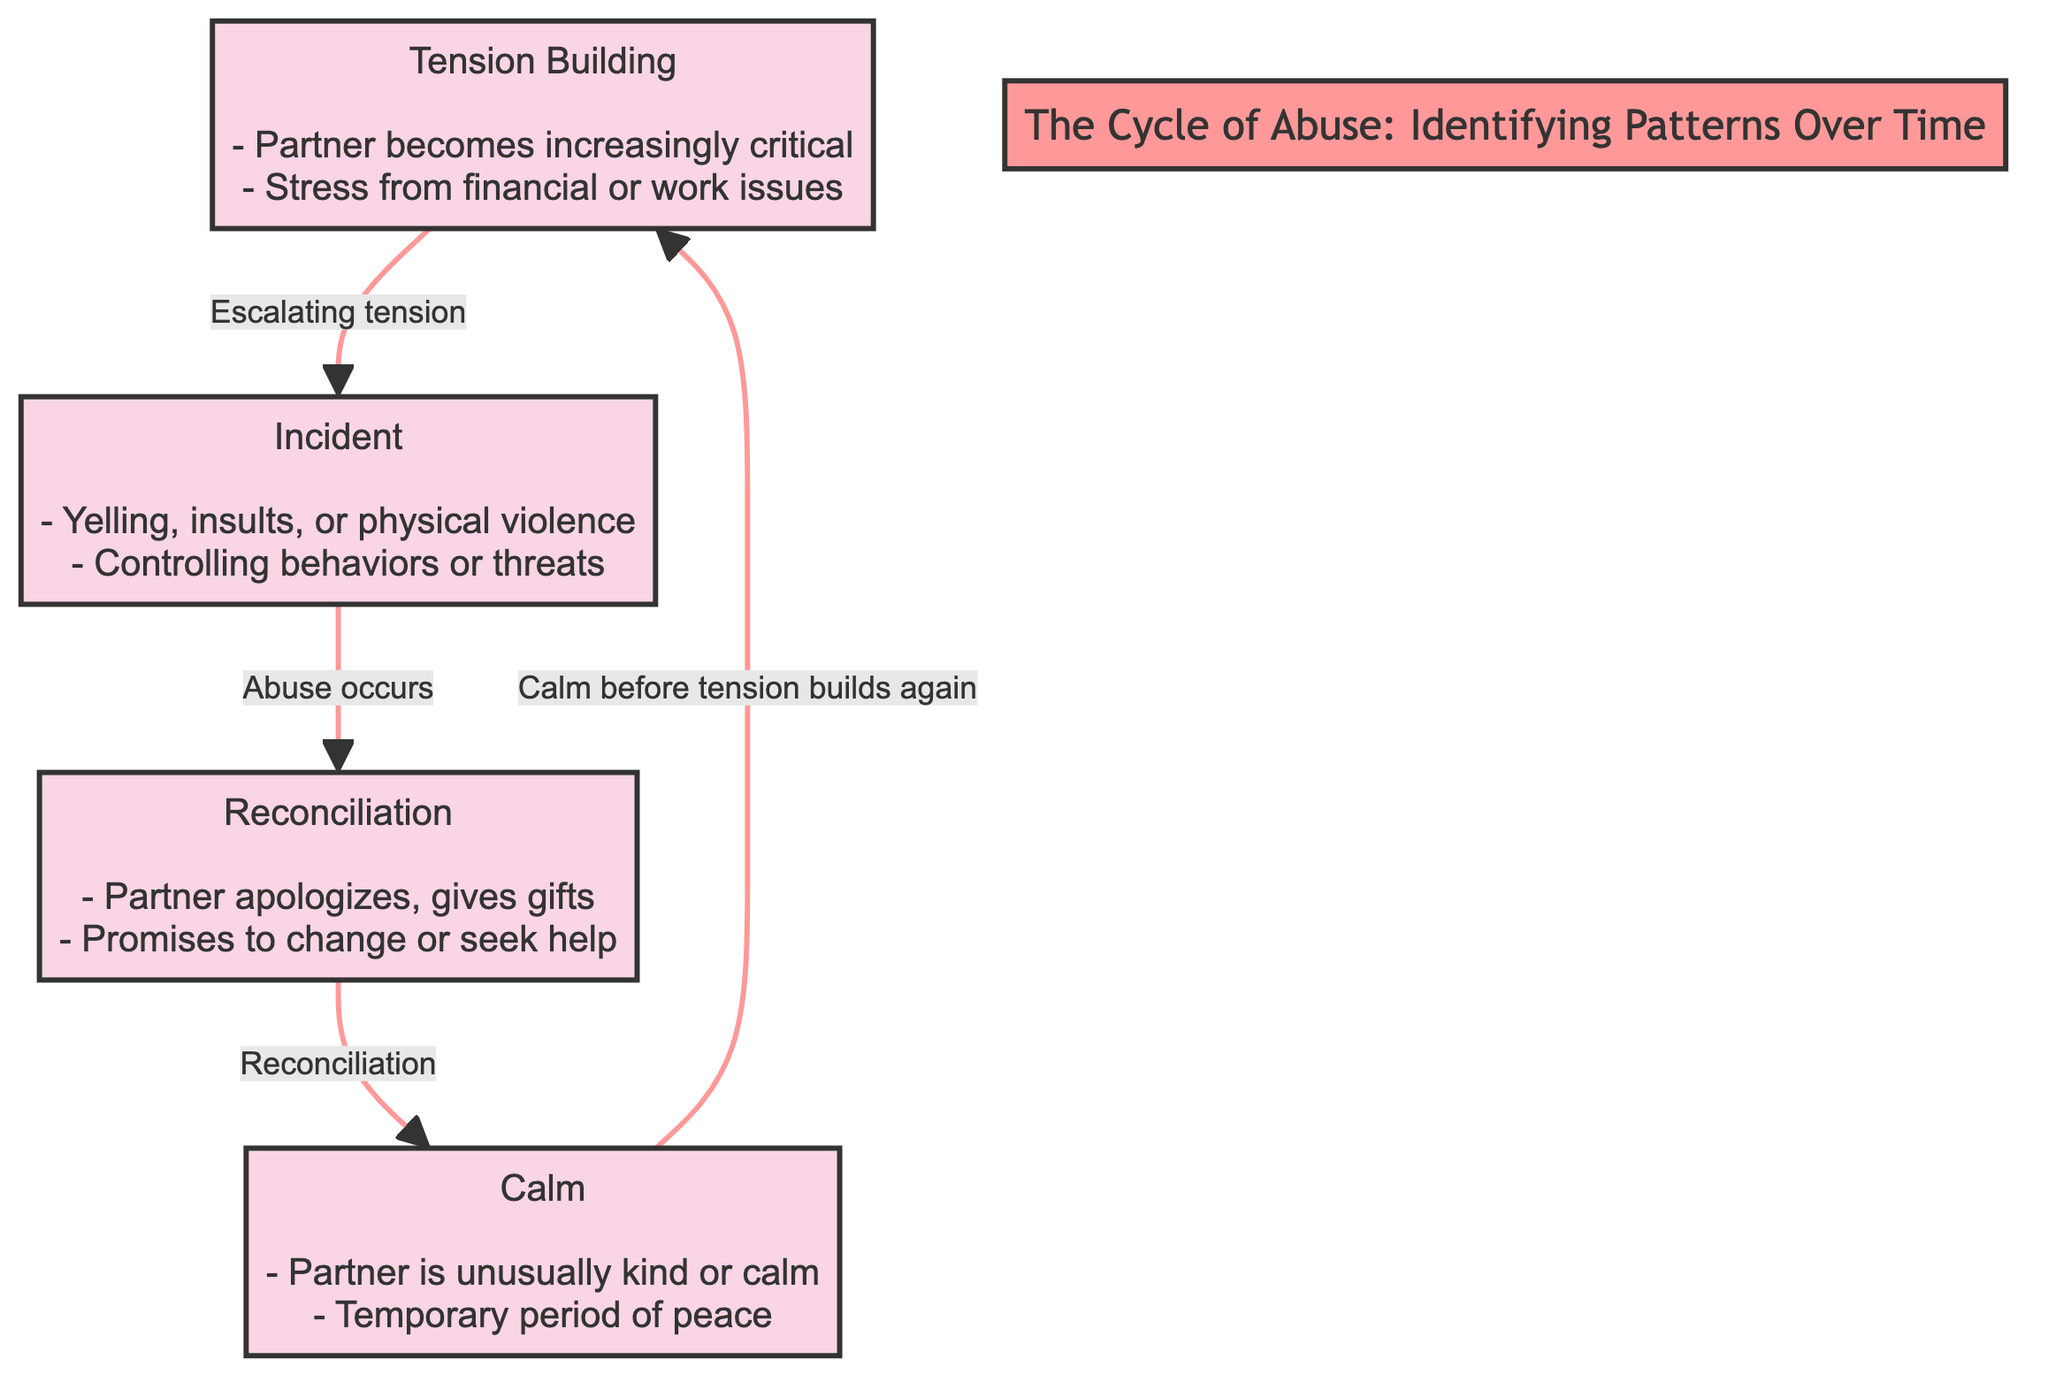What is the first phase in the cycle of abuse? The diagram clearly labels the first phase as "Tension Building" at the top of the flowchart. It is the starting point that leads to the next phase.
Answer: Tension Building How many main phases are represented in the diagram? By examining the diagram, we can identify four main phases: Tension Building, Incident, Reconciliation, and Calm. Each of these phases represents a distinct part of the cycle.
Answer: 4 What behavior is described in the "Incident" phase? The "Incident" phase specifies behaviors such as yelling, insults, or physical violence, and controlling behaviors or threats. These describe the types of abuse that occur during this phase.
Answer: Yelling, insults, physical violence What follows the "Reconciliation" phase in the cycle? The diagram shows that after the "Reconciliation" phase, the next phase is "Calm." This indicates that reconciliation is followed by a temporary peace period.
Answer: Calm What is a key action taken by the partner during the "Reconciliation" phase? According to the diagram, a key action taken during the "Reconciliation" phase includes the partner apologizing and possibly giving gifts. These actions indicate attempts to make amends.
Answer: Apologizes, gives gifts Which phase indicates a temporary period of peace? The diagram specifies that the "Calm" phase represents a temporary period of peace where the partner is unusually kind or calm. This shows a break in the cycle before tension builds again.
Answer: Calm What label connects "Tension Building" to "Incident"? The diagram indicates that "Escalating tension" is the label connecting the "Tension Building" phase to the "Incident" phase, explaining the transition from rising stress to an actual incident of abuse.
Answer: Escalating tension In which phase does the partner make promises to change? The "Reconciliation" phase is where the partner makes promises to change or seek help, as indicated in the diagram. This is a crucial moment of negotiation in the cycle of abuse.
Answer: Reconciliation What visual element distinguishes the phases from the edges? The diagram uses colored nodes (marked as phaseNodes) filled with a light pink shade for phases, while edges are represented simply by lines. This distinction visually separates phase locations from the connections between them.
Answer: Color-coded nodes 